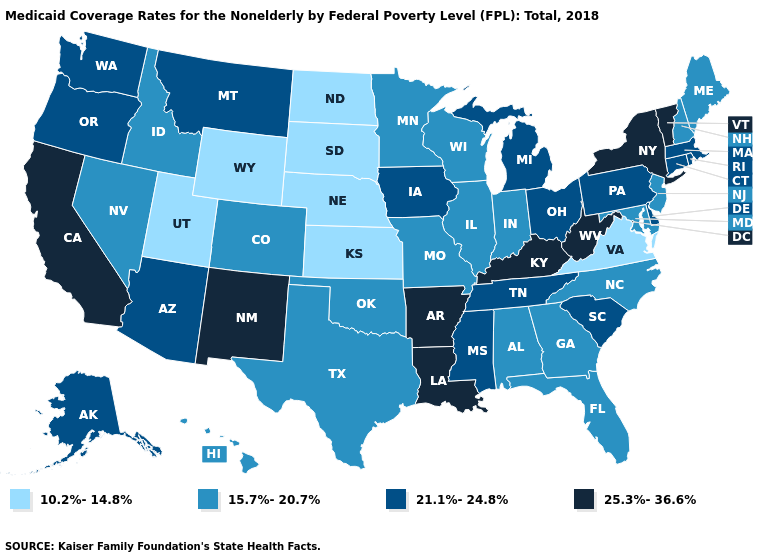What is the value of Texas?
Quick response, please. 15.7%-20.7%. Name the states that have a value in the range 21.1%-24.8%?
Keep it brief. Alaska, Arizona, Connecticut, Delaware, Iowa, Massachusetts, Michigan, Mississippi, Montana, Ohio, Oregon, Pennsylvania, Rhode Island, South Carolina, Tennessee, Washington. Name the states that have a value in the range 15.7%-20.7%?
Answer briefly. Alabama, Colorado, Florida, Georgia, Hawaii, Idaho, Illinois, Indiana, Maine, Maryland, Minnesota, Missouri, Nevada, New Hampshire, New Jersey, North Carolina, Oklahoma, Texas, Wisconsin. Does Washington have the same value as Illinois?
Keep it brief. No. Name the states that have a value in the range 10.2%-14.8%?
Short answer required. Kansas, Nebraska, North Dakota, South Dakota, Utah, Virginia, Wyoming. Does Tennessee have the same value as Massachusetts?
Give a very brief answer. Yes. Name the states that have a value in the range 21.1%-24.8%?
Quick response, please. Alaska, Arizona, Connecticut, Delaware, Iowa, Massachusetts, Michigan, Mississippi, Montana, Ohio, Oregon, Pennsylvania, Rhode Island, South Carolina, Tennessee, Washington. Does Missouri have the lowest value in the MidWest?
Be succinct. No. What is the highest value in the South ?
Give a very brief answer. 25.3%-36.6%. Does Vermont have the highest value in the Northeast?
Short answer required. Yes. Does North Carolina have a higher value than Utah?
Concise answer only. Yes. What is the value of Massachusetts?
Write a very short answer. 21.1%-24.8%. What is the value of Arizona?
Give a very brief answer. 21.1%-24.8%. Which states hav the highest value in the Northeast?
Keep it brief. New York, Vermont. Which states have the lowest value in the USA?
Give a very brief answer. Kansas, Nebraska, North Dakota, South Dakota, Utah, Virginia, Wyoming. 